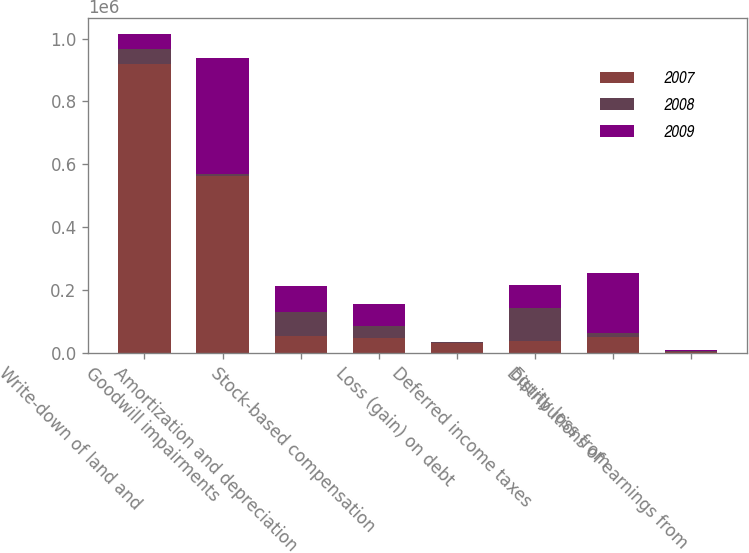Convert chart. <chart><loc_0><loc_0><loc_500><loc_500><stacked_bar_chart><ecel><fcel>Write-down of land and<fcel>Goodwill impairments<fcel>Amortization and depreciation<fcel>Stock-based compensation<fcel>Loss (gain) on debt<fcel>Deferred income taxes<fcel>Equity loss from<fcel>Distributions of earnings from<nl><fcel>2007<fcel>919199<fcel>562990<fcel>54246<fcel>46343<fcel>31594<fcel>37587<fcel>49652<fcel>911<nl><fcel>2008<fcel>47997.5<fcel>5654<fcel>73980<fcel>39107<fcel>1594<fcel>105906<fcel>12813<fcel>4421<nl><fcel>2009<fcel>47997.5<fcel>370023<fcel>83852<fcel>70695<fcel>543<fcel>73164<fcel>190022<fcel>4429<nl></chart> 